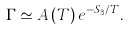<formula> <loc_0><loc_0><loc_500><loc_500>\Gamma \simeq A \left ( T \right ) e ^ { - S _ { 3 } / T } .</formula> 